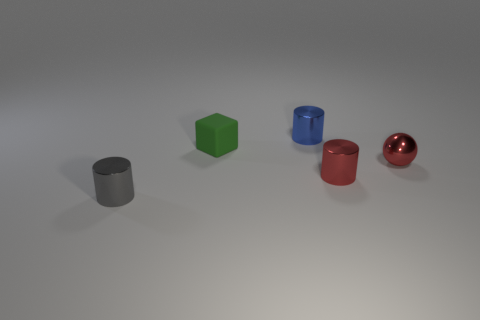Add 2 red cylinders. How many objects exist? 7 Subtract all cylinders. How many objects are left? 2 Subtract all red spheres. Subtract all tiny green rubber objects. How many objects are left? 3 Add 2 shiny objects. How many shiny objects are left? 6 Add 1 blue things. How many blue things exist? 2 Subtract 0 brown blocks. How many objects are left? 5 